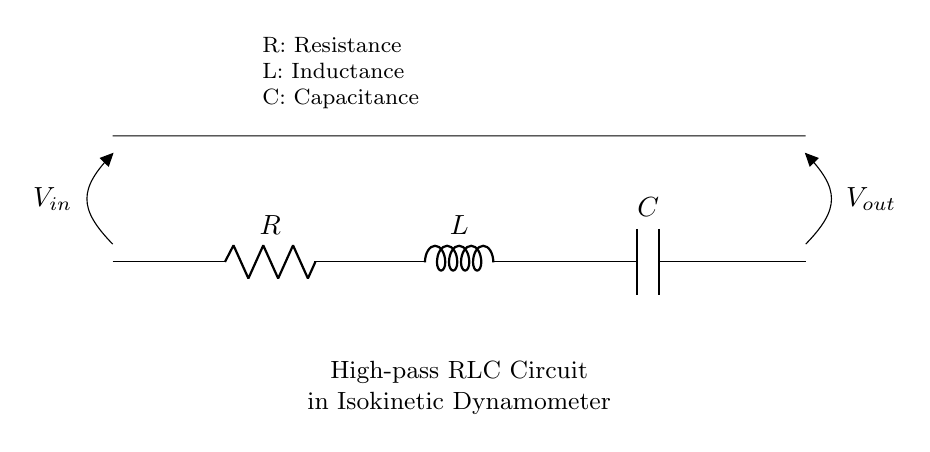What are the three components in this circuit? The circuit includes a resistor, an inductor, and a capacitor, which are labeled as R, L, and C respectively.
Answer: Resistor, Inductor, Capacitor What is the input voltage labeled in the circuit? The input voltage is labeled as V_in in the circuit diagram, indicating the voltage applied to the circuit.
Answer: V_in What is the output voltage of the circuit? The output voltage is labeled as V_out, which is measured across the points where the circuit ends.
Answer: V_out What is the primary function of this circuit type? This circuit functions as a high-pass filter, allowing high-frequency signals to pass while attenuating low-frequency signals.
Answer: High-pass filter How many energy storage elements are in this circuit? The circuit contains two energy storage elements: one inductor and one capacitor. The inductor stores energy in a magnetic field and the capacitor stores energy in an electric field.
Answer: Two What happens to low-frequency signals in this circuit? Low-frequency signals are substantially reduced or blocked due to the characteristics of the high-pass filter, causing them not to reach the output effectively.
Answer: Attenuated or blocked What is the effect of increasing resistance on the circuit's performance? Increasing resistance in this high-pass circuit would typically lead to a decrease in the amplitude of output for a given input, affecting the overall frequency response negatively.
Answer: Decrease in output amplitude 